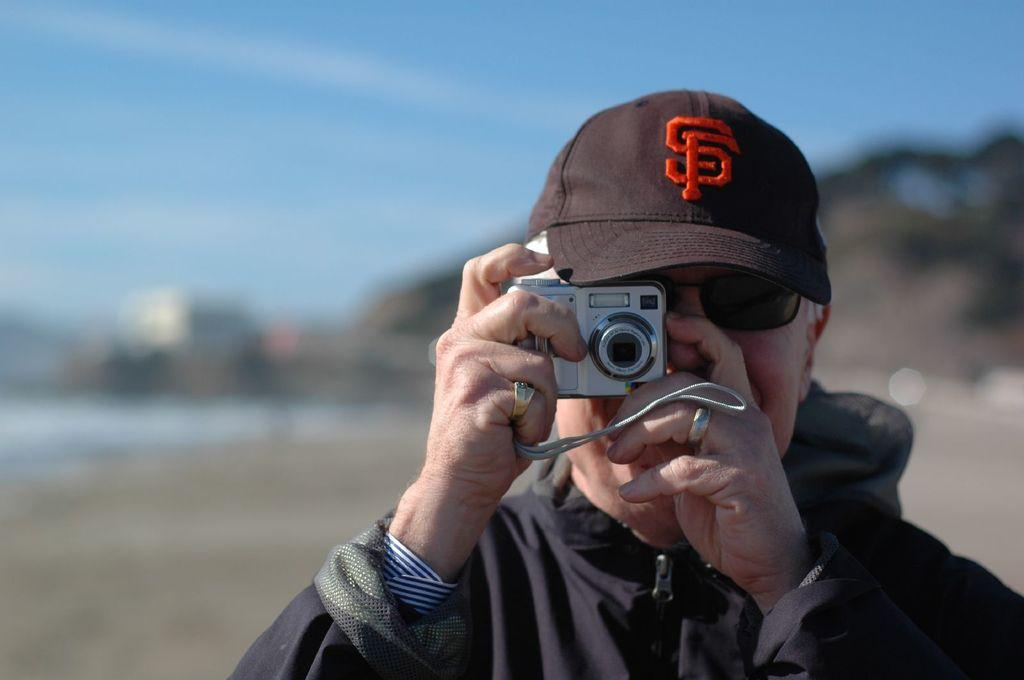What is the main subject of the image? There is a person in the image. What is the person holding in the image? The person is holding a camera. What color is the shirt the person is wearing? The person is wearing a black shirt. What type of headwear is the person wearing? The person is wearing a black hat. What type of eyewear is the person wearing? The person is wearing spex. How would you describe the weather in the image? The background of the image is sunny. What type of coach can be seen in the image? There is no coach present in the image. What type of connection is the person making in the image? The image does not show the person making any connections; they are simply holding a camera. 